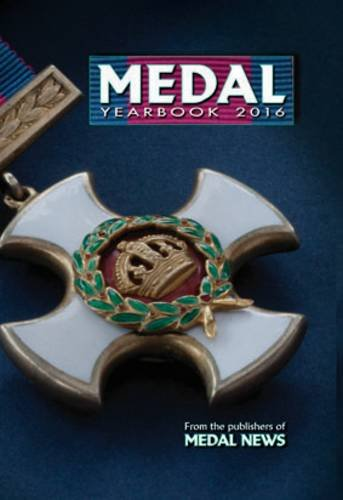What other types of content can be found in the 'Medal Yearbook 2016'? Besides detailed descriptions of various medals, the 'Medal Yearbook 2016' includes information about the manufacturers, the historical context of the medals, and price guides which are valuable for collectors. 